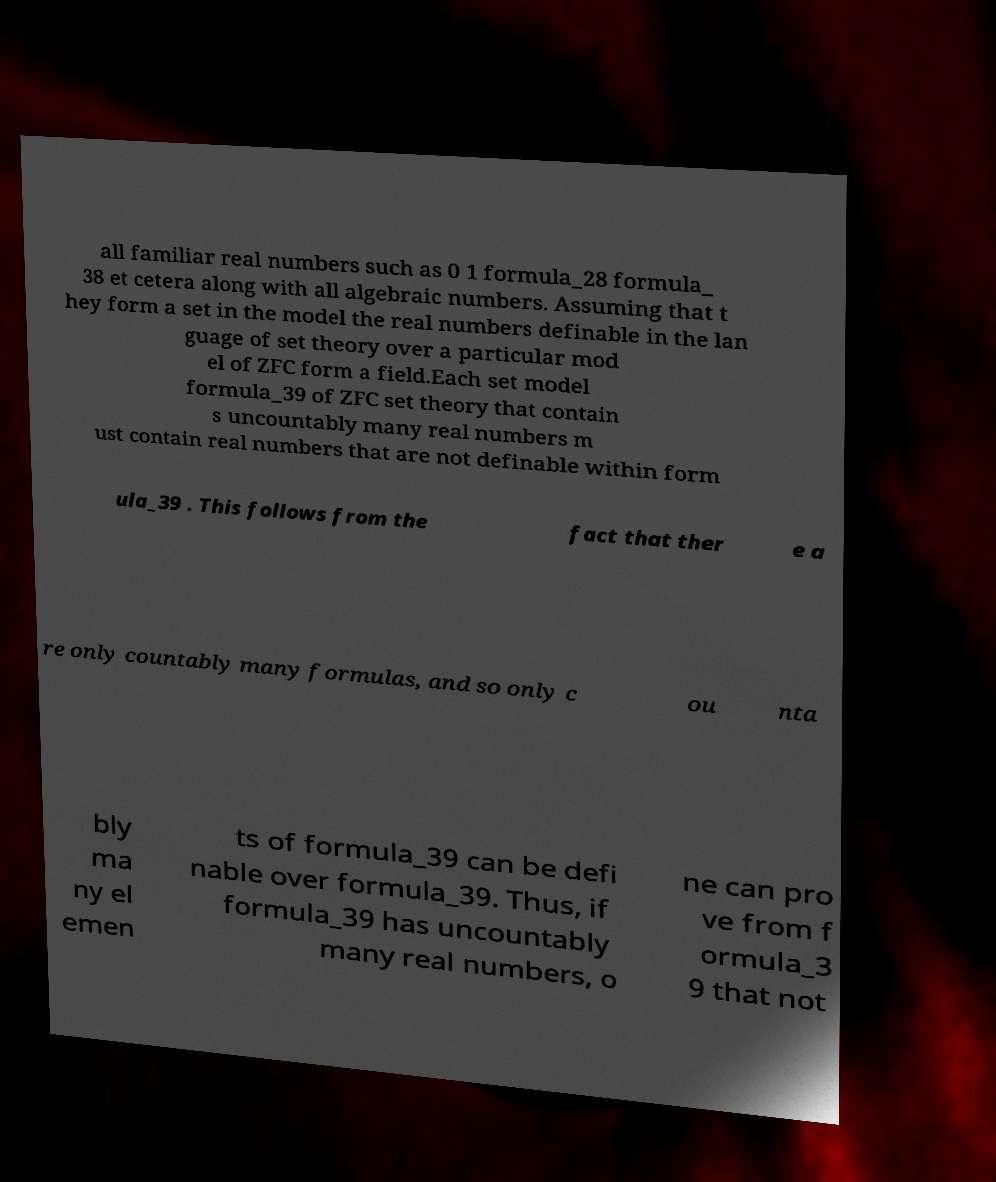For documentation purposes, I need the text within this image transcribed. Could you provide that? all familiar real numbers such as 0 1 formula_28 formula_ 38 et cetera along with all algebraic numbers. Assuming that t hey form a set in the model the real numbers definable in the lan guage of set theory over a particular mod el of ZFC form a field.Each set model formula_39 of ZFC set theory that contain s uncountably many real numbers m ust contain real numbers that are not definable within form ula_39 . This follows from the fact that ther e a re only countably many formulas, and so only c ou nta bly ma ny el emen ts of formula_39 can be defi nable over formula_39. Thus, if formula_39 has uncountably many real numbers, o ne can pro ve from f ormula_3 9 that not 